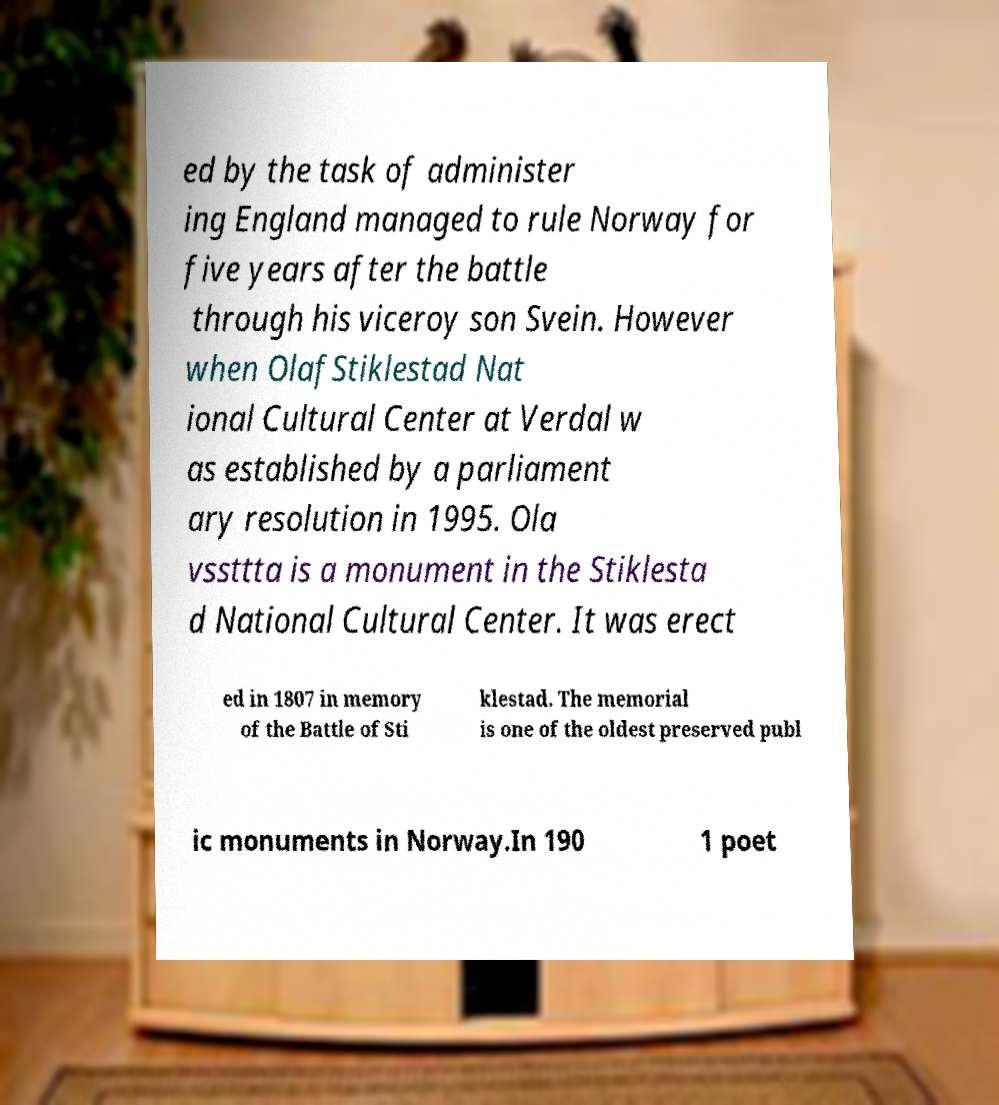Can you read and provide the text displayed in the image?This photo seems to have some interesting text. Can you extract and type it out for me? ed by the task of administer ing England managed to rule Norway for five years after the battle through his viceroy son Svein. However when OlafStiklestad Nat ional Cultural Center at Verdal w as established by a parliament ary resolution in 1995. Ola vssttta is a monument in the Stiklesta d National Cultural Center. It was erect ed in 1807 in memory of the Battle of Sti klestad. The memorial is one of the oldest preserved publ ic monuments in Norway.In 190 1 poet 